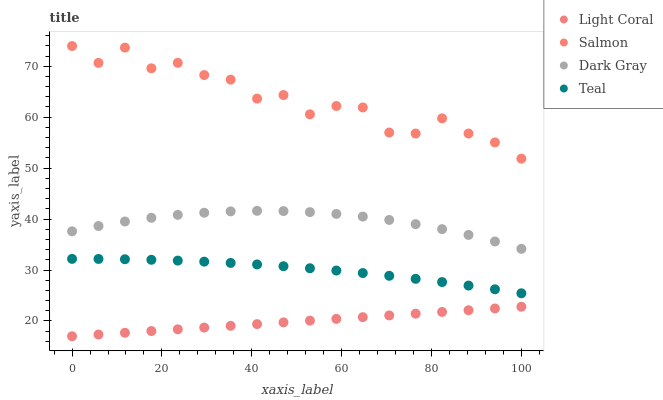Does Light Coral have the minimum area under the curve?
Answer yes or no. Yes. Does Salmon have the maximum area under the curve?
Answer yes or no. Yes. Does Dark Gray have the minimum area under the curve?
Answer yes or no. No. Does Dark Gray have the maximum area under the curve?
Answer yes or no. No. Is Light Coral the smoothest?
Answer yes or no. Yes. Is Salmon the roughest?
Answer yes or no. Yes. Is Dark Gray the smoothest?
Answer yes or no. No. Is Dark Gray the roughest?
Answer yes or no. No. Does Light Coral have the lowest value?
Answer yes or no. Yes. Does Dark Gray have the lowest value?
Answer yes or no. No. Does Salmon have the highest value?
Answer yes or no. Yes. Does Dark Gray have the highest value?
Answer yes or no. No. Is Light Coral less than Dark Gray?
Answer yes or no. Yes. Is Teal greater than Light Coral?
Answer yes or no. Yes. Does Light Coral intersect Dark Gray?
Answer yes or no. No. 